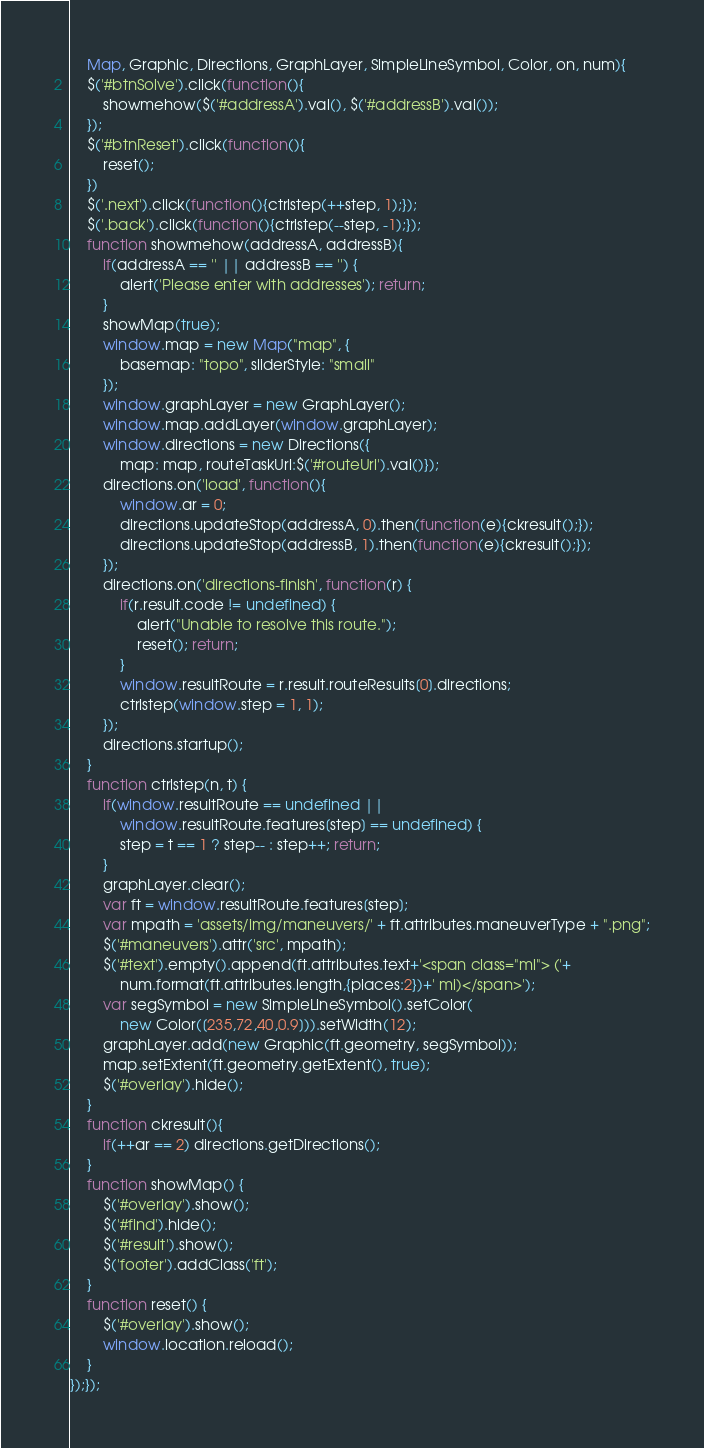Convert code to text. <code><loc_0><loc_0><loc_500><loc_500><_JavaScript_>    Map, Graphic, Directions, GraphLayer, SimpleLineSymbol, Color, on, num){
    $('#btnSolve').click(function(){
        showmehow($('#addressA').val(), $('#addressB').val());
    });
    $('#btnReset').click(function(){
        reset();
    })
    $('.next').click(function(){ctrlstep(++step, 1);});
    $('.back').click(function(){ctrlstep(--step, -1);});
    function showmehow(addressA, addressB){
        if(addressA == '' || addressB == '') {
            alert('Please enter with addresses'); return;
        }
        showMap(true);
        window.map = new Map("map", {
            basemap: "topo", sliderStyle: "small"
        });
        window.graphLayer = new GraphLayer();
        window.map.addLayer(window.graphLayer);
        window.directions = new Directions({
            map: map, routeTaskUrl:$('#routeUrl').val()});
        directions.on('load', function(){
            window.ar = 0;
            directions.updateStop(addressA, 0).then(function(e){ckresult();});
            directions.updateStop(addressB, 1).then(function(e){ckresult();});
        });
        directions.on('directions-finish', function(r) {
            if(r.result.code != undefined) {
                alert("Unable to resolve this route.");
                reset(); return;
            }
            window.resultRoute = r.result.routeResults[0].directions;
            ctrlstep(window.step = 1, 1);
        });
        directions.startup();
    }
    function ctrlstep(n, t) {
        if(window.resultRoute == undefined ||
            window.resultRoute.features[step] == undefined) {
            step = t == 1 ? step-- : step++; return;
        }
        graphLayer.clear();
        var ft = window.resultRoute.features[step];
        var mpath = 'assets/img/maneuvers/' + ft.attributes.maneuverType + ".png";
        $('#maneuvers').attr('src', mpath);
        $('#text').empty().append(ft.attributes.text+'<span class="ml"> ('+
            num.format(ft.attributes.length,{places:2})+' mi)</span>');
        var segSymbol = new SimpleLineSymbol().setColor(
            new Color([235,72,40,0.9])).setWidth(12);
        graphLayer.add(new Graphic(ft.geometry, segSymbol));
        map.setExtent(ft.geometry.getExtent(), true);
        $('#overlay').hide();
    }
    function ckresult(){
        if(++ar == 2) directions.getDirections();
    }
    function showMap() {
        $('#overlay').show();
        $('#find').hide();
        $('#result').show();
        $('footer').addClass('ft');
    }
    function reset() {
        $('#overlay').show();
        window.location.reload();
    }
});});
</code> 